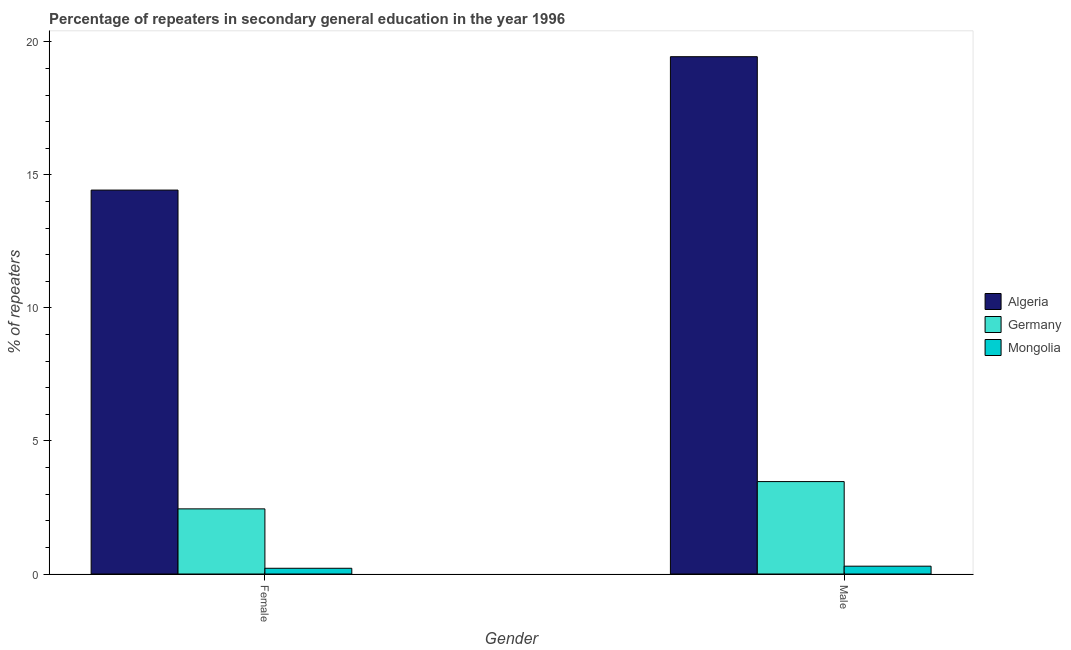What is the label of the 1st group of bars from the left?
Give a very brief answer. Female. What is the percentage of male repeaters in Algeria?
Provide a short and direct response. 19.44. Across all countries, what is the maximum percentage of female repeaters?
Offer a very short reply. 14.43. Across all countries, what is the minimum percentage of female repeaters?
Make the answer very short. 0.22. In which country was the percentage of male repeaters maximum?
Ensure brevity in your answer.  Algeria. In which country was the percentage of male repeaters minimum?
Offer a very short reply. Mongolia. What is the total percentage of female repeaters in the graph?
Provide a succinct answer. 17.09. What is the difference between the percentage of male repeaters in Algeria and that in Mongolia?
Offer a very short reply. 19.15. What is the difference between the percentage of male repeaters in Mongolia and the percentage of female repeaters in Germany?
Offer a terse response. -2.15. What is the average percentage of male repeaters per country?
Provide a succinct answer. 7.74. What is the difference between the percentage of female repeaters and percentage of male repeaters in Germany?
Offer a very short reply. -1.03. What is the ratio of the percentage of female repeaters in Mongolia to that in Germany?
Offer a terse response. 0.09. Is the percentage of female repeaters in Germany less than that in Mongolia?
Give a very brief answer. No. What does the 2nd bar from the left in Male represents?
Your response must be concise. Germany. What does the 2nd bar from the right in Female represents?
Give a very brief answer. Germany. How many countries are there in the graph?
Ensure brevity in your answer.  3. Are the values on the major ticks of Y-axis written in scientific E-notation?
Keep it short and to the point. No. Where does the legend appear in the graph?
Ensure brevity in your answer.  Center right. How many legend labels are there?
Keep it short and to the point. 3. What is the title of the graph?
Your response must be concise. Percentage of repeaters in secondary general education in the year 1996. Does "Switzerland" appear as one of the legend labels in the graph?
Provide a short and direct response. No. What is the label or title of the Y-axis?
Keep it short and to the point. % of repeaters. What is the % of repeaters in Algeria in Female?
Your answer should be compact. 14.43. What is the % of repeaters in Germany in Female?
Make the answer very short. 2.45. What is the % of repeaters of Mongolia in Female?
Offer a terse response. 0.22. What is the % of repeaters in Algeria in Male?
Give a very brief answer. 19.44. What is the % of repeaters in Germany in Male?
Make the answer very short. 3.47. What is the % of repeaters of Mongolia in Male?
Offer a terse response. 0.29. Across all Gender, what is the maximum % of repeaters in Algeria?
Make the answer very short. 19.44. Across all Gender, what is the maximum % of repeaters of Germany?
Provide a succinct answer. 3.47. Across all Gender, what is the maximum % of repeaters of Mongolia?
Offer a terse response. 0.29. Across all Gender, what is the minimum % of repeaters of Algeria?
Provide a short and direct response. 14.43. Across all Gender, what is the minimum % of repeaters in Germany?
Give a very brief answer. 2.45. Across all Gender, what is the minimum % of repeaters in Mongolia?
Your response must be concise. 0.22. What is the total % of repeaters in Algeria in the graph?
Your answer should be compact. 33.87. What is the total % of repeaters in Germany in the graph?
Offer a very short reply. 5.92. What is the total % of repeaters of Mongolia in the graph?
Offer a terse response. 0.51. What is the difference between the % of repeaters of Algeria in Female and that in Male?
Give a very brief answer. -5.01. What is the difference between the % of repeaters of Germany in Female and that in Male?
Provide a short and direct response. -1.03. What is the difference between the % of repeaters of Mongolia in Female and that in Male?
Make the answer very short. -0.08. What is the difference between the % of repeaters of Algeria in Female and the % of repeaters of Germany in Male?
Provide a short and direct response. 10.96. What is the difference between the % of repeaters in Algeria in Female and the % of repeaters in Mongolia in Male?
Provide a short and direct response. 14.14. What is the difference between the % of repeaters of Germany in Female and the % of repeaters of Mongolia in Male?
Provide a short and direct response. 2.15. What is the average % of repeaters in Algeria per Gender?
Provide a short and direct response. 16.94. What is the average % of repeaters of Germany per Gender?
Your answer should be compact. 2.96. What is the average % of repeaters in Mongolia per Gender?
Offer a terse response. 0.25. What is the difference between the % of repeaters of Algeria and % of repeaters of Germany in Female?
Your answer should be very brief. 11.98. What is the difference between the % of repeaters of Algeria and % of repeaters of Mongolia in Female?
Offer a very short reply. 14.21. What is the difference between the % of repeaters of Germany and % of repeaters of Mongolia in Female?
Give a very brief answer. 2.23. What is the difference between the % of repeaters of Algeria and % of repeaters of Germany in Male?
Provide a short and direct response. 15.97. What is the difference between the % of repeaters in Algeria and % of repeaters in Mongolia in Male?
Keep it short and to the point. 19.15. What is the difference between the % of repeaters in Germany and % of repeaters in Mongolia in Male?
Your answer should be compact. 3.18. What is the ratio of the % of repeaters of Algeria in Female to that in Male?
Give a very brief answer. 0.74. What is the ratio of the % of repeaters of Germany in Female to that in Male?
Your answer should be compact. 0.7. What is the ratio of the % of repeaters of Mongolia in Female to that in Male?
Give a very brief answer. 0.73. What is the difference between the highest and the second highest % of repeaters of Algeria?
Your answer should be compact. 5.01. What is the difference between the highest and the second highest % of repeaters in Germany?
Your answer should be very brief. 1.03. What is the difference between the highest and the second highest % of repeaters in Mongolia?
Your response must be concise. 0.08. What is the difference between the highest and the lowest % of repeaters of Algeria?
Provide a succinct answer. 5.01. What is the difference between the highest and the lowest % of repeaters in Germany?
Ensure brevity in your answer.  1.03. What is the difference between the highest and the lowest % of repeaters of Mongolia?
Make the answer very short. 0.08. 